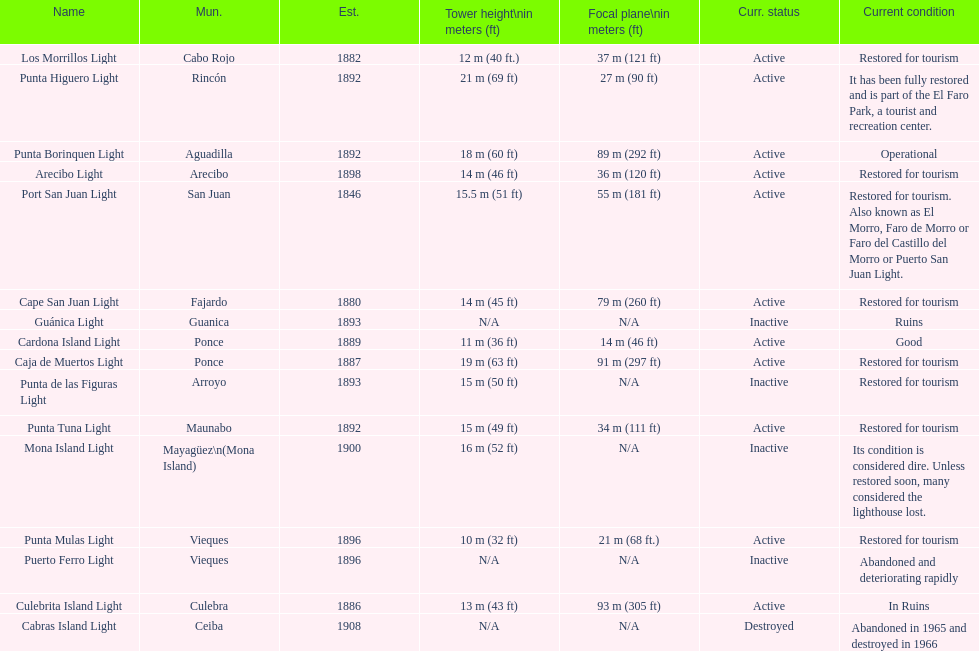The difference in years from 1882 to 1889 7. 